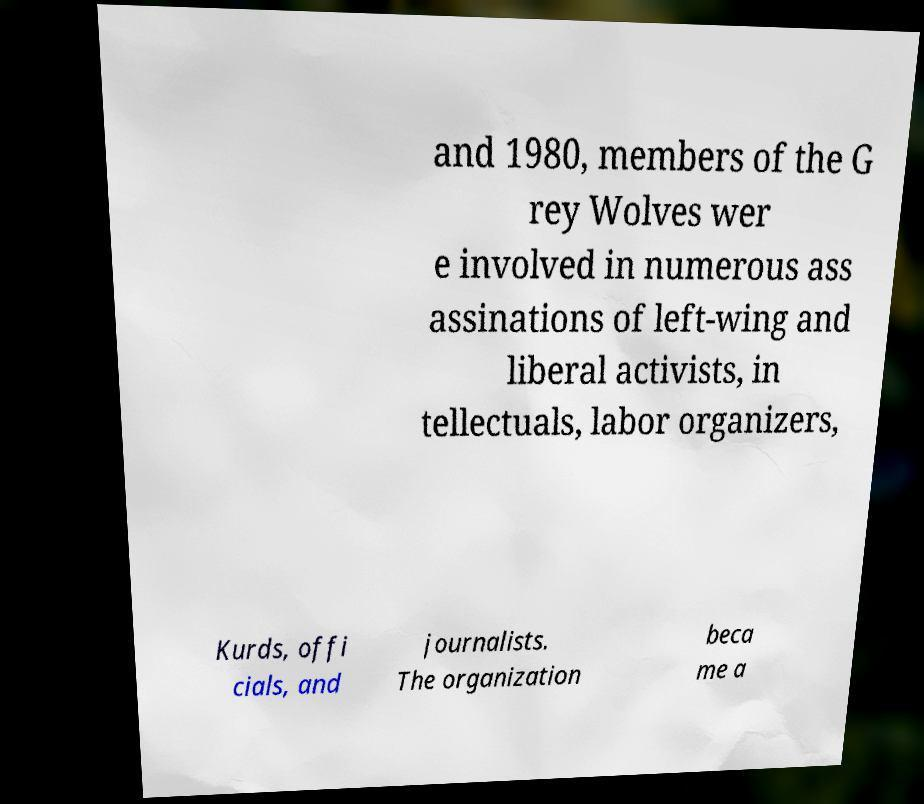Could you assist in decoding the text presented in this image and type it out clearly? and 1980, members of the G rey Wolves wer e involved in numerous ass assinations of left-wing and liberal activists, in tellectuals, labor organizers, Kurds, offi cials, and journalists. The organization beca me a 